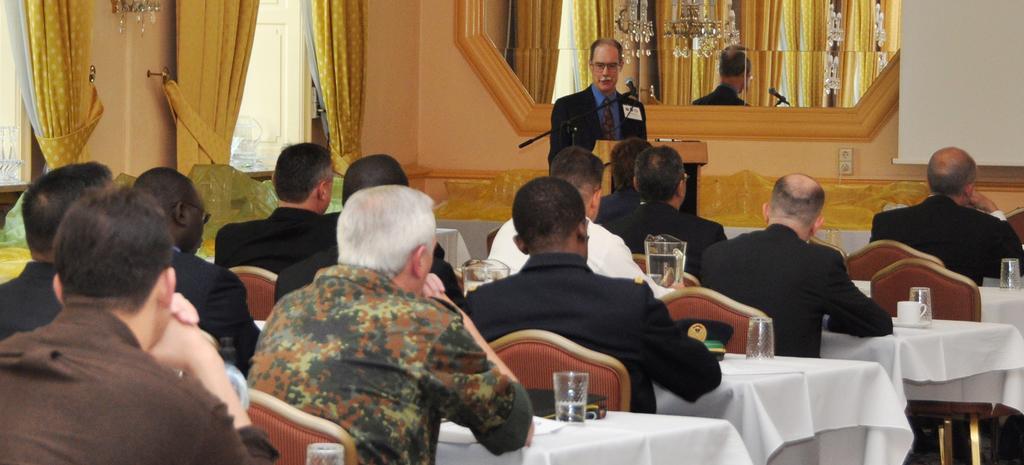Describe this image in one or two sentences. In this image I can see people sitting on the chairs, there are white tables in front of them on which there are cups, saucers, glasses and jugs. A person is standing at the back, wearing a suit. There is a microphone and its stand on front of him. There is a mirror at the back. There are curtains, doors and a chandelier on the left. 